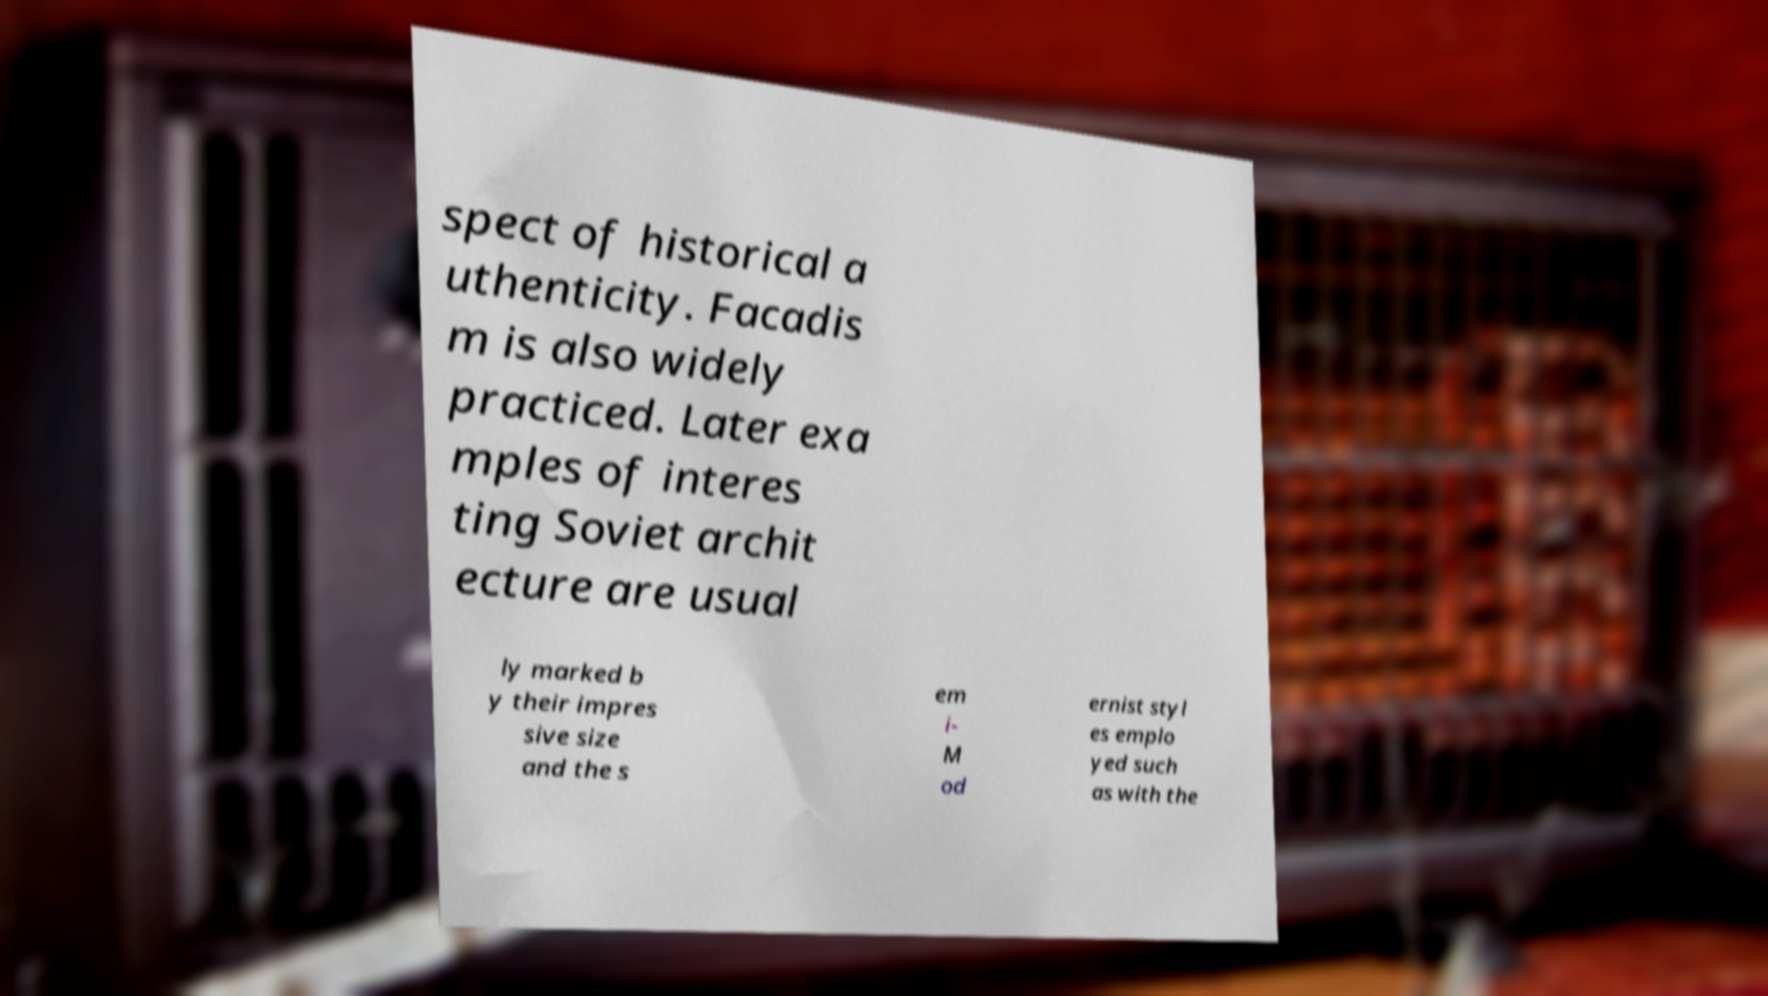Can you accurately transcribe the text from the provided image for me? spect of historical a uthenticity. Facadis m is also widely practiced. Later exa mples of interes ting Soviet archit ecture are usual ly marked b y their impres sive size and the s em i- M od ernist styl es emplo yed such as with the 